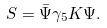<formula> <loc_0><loc_0><loc_500><loc_500>S = \bar { \Psi } \gamma _ { 5 } K \Psi .</formula> 